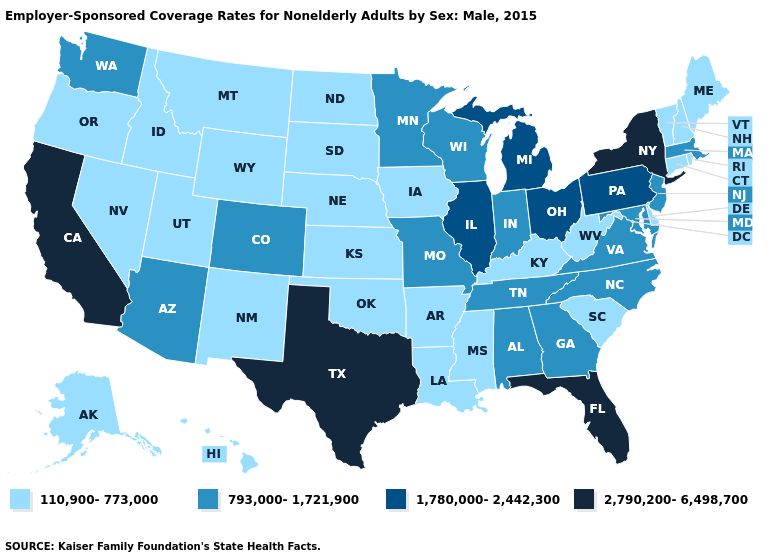Is the legend a continuous bar?
Concise answer only. No. Does Utah have a lower value than California?
Be succinct. Yes. Name the states that have a value in the range 793,000-1,721,900?
Concise answer only. Alabama, Arizona, Colorado, Georgia, Indiana, Maryland, Massachusetts, Minnesota, Missouri, New Jersey, North Carolina, Tennessee, Virginia, Washington, Wisconsin. How many symbols are there in the legend?
Short answer required. 4. What is the value of Delaware?
Write a very short answer. 110,900-773,000. Name the states that have a value in the range 2,790,200-6,498,700?
Be succinct. California, Florida, New York, Texas. Name the states that have a value in the range 793,000-1,721,900?
Keep it brief. Alabama, Arizona, Colorado, Georgia, Indiana, Maryland, Massachusetts, Minnesota, Missouri, New Jersey, North Carolina, Tennessee, Virginia, Washington, Wisconsin. Does Mississippi have the lowest value in the USA?
Write a very short answer. Yes. Does Arkansas have the highest value in the USA?
Be succinct. No. What is the lowest value in the West?
Short answer required. 110,900-773,000. Does Minnesota have the lowest value in the USA?
Give a very brief answer. No. What is the value of Nevada?
Give a very brief answer. 110,900-773,000. What is the highest value in the USA?
Give a very brief answer. 2,790,200-6,498,700. What is the lowest value in the USA?
Answer briefly. 110,900-773,000. What is the lowest value in the USA?
Quick response, please. 110,900-773,000. 